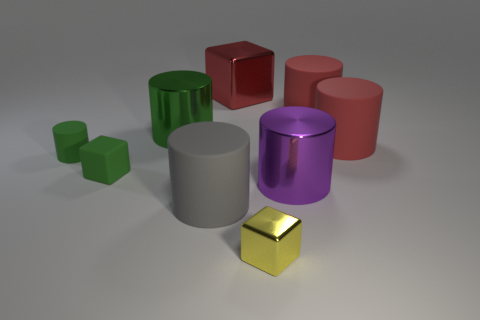Subtract 3 cylinders. How many cylinders are left? 3 Subtract all green cylinders. How many cylinders are left? 4 Subtract all large gray cylinders. How many cylinders are left? 5 Subtract all blue cylinders. Subtract all brown balls. How many cylinders are left? 6 Add 1 big gray things. How many objects exist? 10 Subtract all cylinders. How many objects are left? 3 Subtract 0 brown cylinders. How many objects are left? 9 Subtract all large purple shiny objects. Subtract all green rubber cylinders. How many objects are left? 7 Add 6 large red cubes. How many large red cubes are left? 7 Add 7 purple objects. How many purple objects exist? 8 